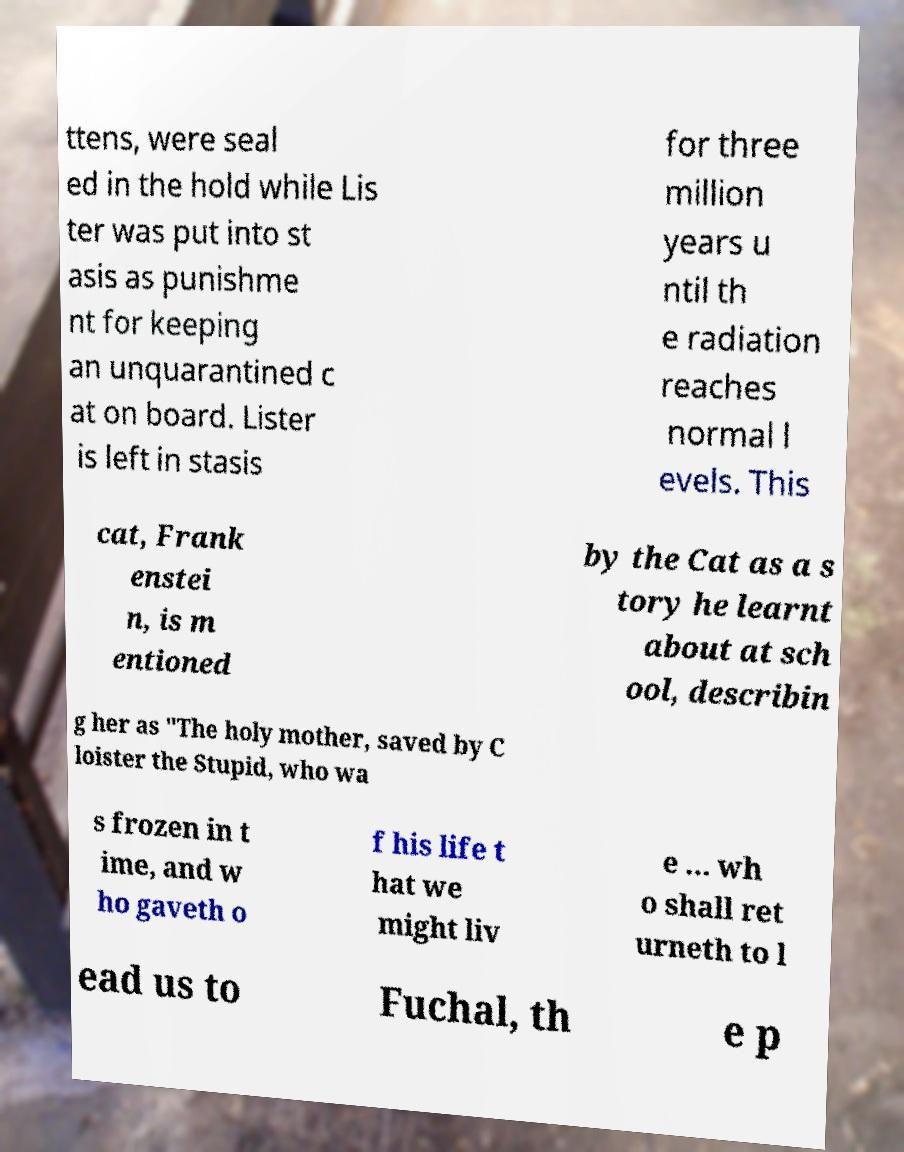Could you assist in decoding the text presented in this image and type it out clearly? ttens, were seal ed in the hold while Lis ter was put into st asis as punishme nt for keeping an unquarantined c at on board. Lister is left in stasis for three million years u ntil th e radiation reaches normal l evels. This cat, Frank enstei n, is m entioned by the Cat as a s tory he learnt about at sch ool, describin g her as "The holy mother, saved by C loister the Stupid, who wa s frozen in t ime, and w ho gaveth o f his life t hat we might liv e ... wh o shall ret urneth to l ead us to Fuchal, th e p 